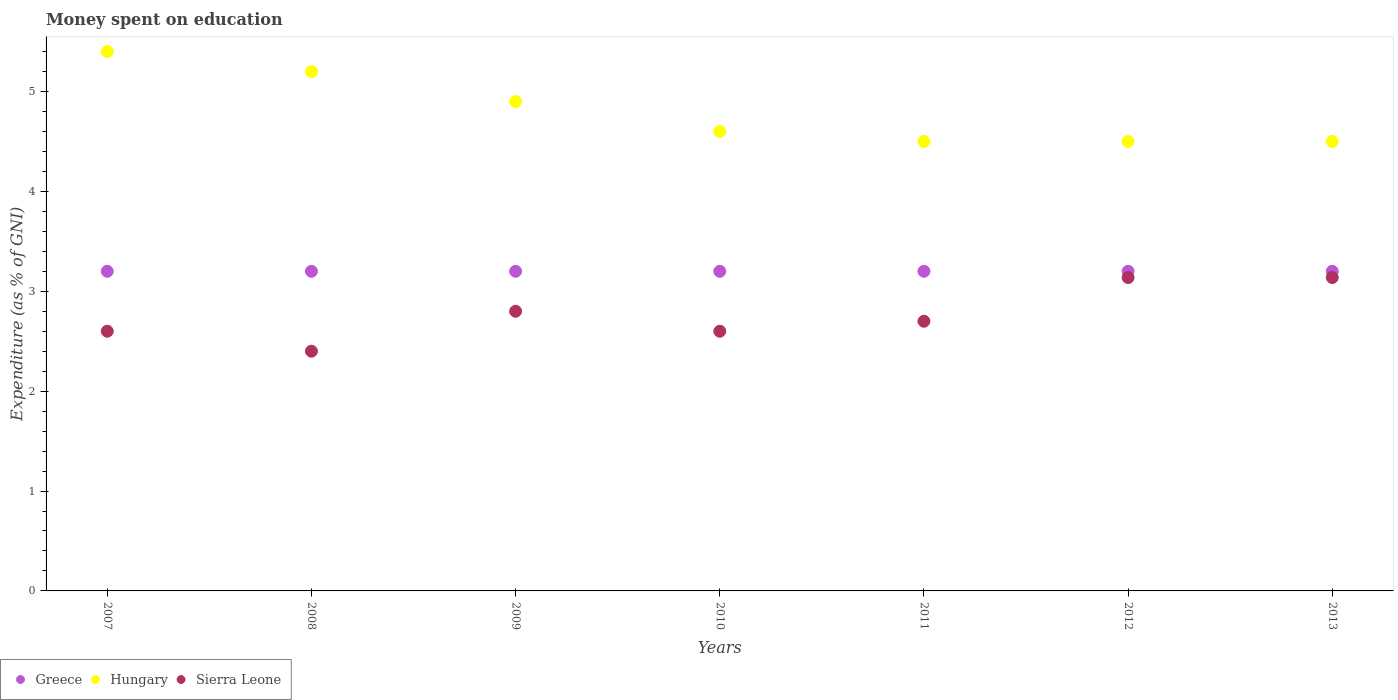What is the amount of money spent on education in Hungary in 2010?
Give a very brief answer. 4.6. Across all years, what is the maximum amount of money spent on education in Sierra Leone?
Your answer should be very brief. 3.14. Across all years, what is the minimum amount of money spent on education in Hungary?
Provide a short and direct response. 4.5. In which year was the amount of money spent on education in Sierra Leone minimum?
Your answer should be compact. 2008. What is the total amount of money spent on education in Greece in the graph?
Your response must be concise. 22.4. What is the difference between the amount of money spent on education in Sierra Leone in 2009 and that in 2013?
Your response must be concise. -0.34. What is the average amount of money spent on education in Hungary per year?
Keep it short and to the point. 4.8. In the year 2012, what is the difference between the amount of money spent on education in Sierra Leone and amount of money spent on education in Hungary?
Your answer should be very brief. -1.36. What is the ratio of the amount of money spent on education in Sierra Leone in 2010 to that in 2011?
Ensure brevity in your answer.  0.96. What is the difference between the highest and the second highest amount of money spent on education in Hungary?
Give a very brief answer. 0.2. Is the sum of the amount of money spent on education in Hungary in 2008 and 2009 greater than the maximum amount of money spent on education in Greece across all years?
Your response must be concise. Yes. Is it the case that in every year, the sum of the amount of money spent on education in Greece and amount of money spent on education in Sierra Leone  is greater than the amount of money spent on education in Hungary?
Offer a very short reply. Yes. Is the amount of money spent on education in Sierra Leone strictly greater than the amount of money spent on education in Greece over the years?
Your response must be concise. No. Is the amount of money spent on education in Hungary strictly less than the amount of money spent on education in Greece over the years?
Offer a very short reply. No. Are the values on the major ticks of Y-axis written in scientific E-notation?
Your answer should be very brief. No. Does the graph contain any zero values?
Ensure brevity in your answer.  No. What is the title of the graph?
Provide a succinct answer. Money spent on education. What is the label or title of the X-axis?
Ensure brevity in your answer.  Years. What is the label or title of the Y-axis?
Keep it short and to the point. Expenditure (as % of GNI). What is the Expenditure (as % of GNI) of Greece in 2007?
Your response must be concise. 3.2. What is the Expenditure (as % of GNI) of Sierra Leone in 2008?
Your answer should be very brief. 2.4. What is the Expenditure (as % of GNI) of Hungary in 2009?
Provide a succinct answer. 4.9. What is the Expenditure (as % of GNI) of Greece in 2010?
Your response must be concise. 3.2. What is the Expenditure (as % of GNI) of Sierra Leone in 2010?
Keep it short and to the point. 2.6. What is the Expenditure (as % of GNI) in Hungary in 2011?
Your response must be concise. 4.5. What is the Expenditure (as % of GNI) in Greece in 2012?
Your answer should be very brief. 3.2. What is the Expenditure (as % of GNI) of Sierra Leone in 2012?
Make the answer very short. 3.14. What is the Expenditure (as % of GNI) in Greece in 2013?
Offer a terse response. 3.2. What is the Expenditure (as % of GNI) of Sierra Leone in 2013?
Provide a short and direct response. 3.14. Across all years, what is the maximum Expenditure (as % of GNI) in Greece?
Offer a terse response. 3.2. Across all years, what is the maximum Expenditure (as % of GNI) in Sierra Leone?
Offer a terse response. 3.14. Across all years, what is the minimum Expenditure (as % of GNI) of Greece?
Offer a very short reply. 3.2. Across all years, what is the minimum Expenditure (as % of GNI) in Sierra Leone?
Provide a succinct answer. 2.4. What is the total Expenditure (as % of GNI) of Greece in the graph?
Provide a succinct answer. 22.4. What is the total Expenditure (as % of GNI) in Hungary in the graph?
Your answer should be compact. 33.6. What is the total Expenditure (as % of GNI) in Sierra Leone in the graph?
Provide a short and direct response. 19.37. What is the difference between the Expenditure (as % of GNI) of Greece in 2007 and that in 2008?
Make the answer very short. 0. What is the difference between the Expenditure (as % of GNI) in Hungary in 2007 and that in 2008?
Your answer should be compact. 0.2. What is the difference between the Expenditure (as % of GNI) in Sierra Leone in 2007 and that in 2008?
Make the answer very short. 0.2. What is the difference between the Expenditure (as % of GNI) of Greece in 2007 and that in 2009?
Your response must be concise. 0. What is the difference between the Expenditure (as % of GNI) of Hungary in 2007 and that in 2010?
Offer a very short reply. 0.8. What is the difference between the Expenditure (as % of GNI) of Sierra Leone in 2007 and that in 2010?
Your response must be concise. 0. What is the difference between the Expenditure (as % of GNI) of Sierra Leone in 2007 and that in 2011?
Offer a terse response. -0.1. What is the difference between the Expenditure (as % of GNI) in Greece in 2007 and that in 2012?
Make the answer very short. 0. What is the difference between the Expenditure (as % of GNI) in Hungary in 2007 and that in 2012?
Give a very brief answer. 0.9. What is the difference between the Expenditure (as % of GNI) of Sierra Leone in 2007 and that in 2012?
Offer a terse response. -0.54. What is the difference between the Expenditure (as % of GNI) of Sierra Leone in 2007 and that in 2013?
Your response must be concise. -0.54. What is the difference between the Expenditure (as % of GNI) in Greece in 2008 and that in 2009?
Keep it short and to the point. 0. What is the difference between the Expenditure (as % of GNI) of Greece in 2008 and that in 2011?
Keep it short and to the point. 0. What is the difference between the Expenditure (as % of GNI) of Hungary in 2008 and that in 2011?
Your answer should be compact. 0.7. What is the difference between the Expenditure (as % of GNI) of Hungary in 2008 and that in 2012?
Provide a succinct answer. 0.7. What is the difference between the Expenditure (as % of GNI) of Sierra Leone in 2008 and that in 2012?
Ensure brevity in your answer.  -0.74. What is the difference between the Expenditure (as % of GNI) in Greece in 2008 and that in 2013?
Provide a short and direct response. 0. What is the difference between the Expenditure (as % of GNI) of Hungary in 2008 and that in 2013?
Ensure brevity in your answer.  0.7. What is the difference between the Expenditure (as % of GNI) in Sierra Leone in 2008 and that in 2013?
Give a very brief answer. -0.74. What is the difference between the Expenditure (as % of GNI) in Greece in 2009 and that in 2010?
Provide a short and direct response. 0. What is the difference between the Expenditure (as % of GNI) in Hungary in 2009 and that in 2010?
Your answer should be compact. 0.3. What is the difference between the Expenditure (as % of GNI) of Sierra Leone in 2009 and that in 2010?
Make the answer very short. 0.2. What is the difference between the Expenditure (as % of GNI) of Hungary in 2009 and that in 2011?
Make the answer very short. 0.4. What is the difference between the Expenditure (as % of GNI) in Sierra Leone in 2009 and that in 2011?
Your answer should be compact. 0.1. What is the difference between the Expenditure (as % of GNI) of Greece in 2009 and that in 2012?
Provide a succinct answer. 0. What is the difference between the Expenditure (as % of GNI) of Sierra Leone in 2009 and that in 2012?
Give a very brief answer. -0.34. What is the difference between the Expenditure (as % of GNI) of Hungary in 2009 and that in 2013?
Your answer should be compact. 0.4. What is the difference between the Expenditure (as % of GNI) in Sierra Leone in 2009 and that in 2013?
Offer a terse response. -0.34. What is the difference between the Expenditure (as % of GNI) of Greece in 2010 and that in 2011?
Make the answer very short. 0. What is the difference between the Expenditure (as % of GNI) in Sierra Leone in 2010 and that in 2012?
Your answer should be very brief. -0.54. What is the difference between the Expenditure (as % of GNI) in Sierra Leone in 2010 and that in 2013?
Provide a short and direct response. -0.54. What is the difference between the Expenditure (as % of GNI) of Sierra Leone in 2011 and that in 2012?
Provide a succinct answer. -0.44. What is the difference between the Expenditure (as % of GNI) in Sierra Leone in 2011 and that in 2013?
Your answer should be compact. -0.44. What is the difference between the Expenditure (as % of GNI) in Greece in 2012 and that in 2013?
Offer a very short reply. 0. What is the difference between the Expenditure (as % of GNI) in Sierra Leone in 2012 and that in 2013?
Ensure brevity in your answer.  0. What is the difference between the Expenditure (as % of GNI) in Greece in 2007 and the Expenditure (as % of GNI) in Hungary in 2008?
Make the answer very short. -2. What is the difference between the Expenditure (as % of GNI) of Hungary in 2007 and the Expenditure (as % of GNI) of Sierra Leone in 2008?
Your answer should be very brief. 3. What is the difference between the Expenditure (as % of GNI) in Greece in 2007 and the Expenditure (as % of GNI) in Hungary in 2009?
Provide a short and direct response. -1.7. What is the difference between the Expenditure (as % of GNI) in Hungary in 2007 and the Expenditure (as % of GNI) in Sierra Leone in 2009?
Offer a very short reply. 2.6. What is the difference between the Expenditure (as % of GNI) of Greece in 2007 and the Expenditure (as % of GNI) of Hungary in 2010?
Make the answer very short. -1.4. What is the difference between the Expenditure (as % of GNI) of Greece in 2007 and the Expenditure (as % of GNI) of Sierra Leone in 2010?
Offer a very short reply. 0.6. What is the difference between the Expenditure (as % of GNI) of Hungary in 2007 and the Expenditure (as % of GNI) of Sierra Leone in 2010?
Ensure brevity in your answer.  2.8. What is the difference between the Expenditure (as % of GNI) of Greece in 2007 and the Expenditure (as % of GNI) of Hungary in 2011?
Your answer should be very brief. -1.3. What is the difference between the Expenditure (as % of GNI) of Greece in 2007 and the Expenditure (as % of GNI) of Sierra Leone in 2011?
Your answer should be compact. 0.5. What is the difference between the Expenditure (as % of GNI) in Greece in 2007 and the Expenditure (as % of GNI) in Sierra Leone in 2012?
Provide a succinct answer. 0.06. What is the difference between the Expenditure (as % of GNI) of Hungary in 2007 and the Expenditure (as % of GNI) of Sierra Leone in 2012?
Offer a very short reply. 2.26. What is the difference between the Expenditure (as % of GNI) in Greece in 2007 and the Expenditure (as % of GNI) in Hungary in 2013?
Provide a succinct answer. -1.3. What is the difference between the Expenditure (as % of GNI) in Greece in 2007 and the Expenditure (as % of GNI) in Sierra Leone in 2013?
Give a very brief answer. 0.06. What is the difference between the Expenditure (as % of GNI) in Hungary in 2007 and the Expenditure (as % of GNI) in Sierra Leone in 2013?
Offer a very short reply. 2.26. What is the difference between the Expenditure (as % of GNI) of Greece in 2008 and the Expenditure (as % of GNI) of Hungary in 2009?
Provide a short and direct response. -1.7. What is the difference between the Expenditure (as % of GNI) in Hungary in 2008 and the Expenditure (as % of GNI) in Sierra Leone in 2009?
Your response must be concise. 2.4. What is the difference between the Expenditure (as % of GNI) of Greece in 2008 and the Expenditure (as % of GNI) of Hungary in 2010?
Offer a very short reply. -1.4. What is the difference between the Expenditure (as % of GNI) of Hungary in 2008 and the Expenditure (as % of GNI) of Sierra Leone in 2010?
Your response must be concise. 2.6. What is the difference between the Expenditure (as % of GNI) of Hungary in 2008 and the Expenditure (as % of GNI) of Sierra Leone in 2011?
Your answer should be compact. 2.5. What is the difference between the Expenditure (as % of GNI) of Greece in 2008 and the Expenditure (as % of GNI) of Sierra Leone in 2012?
Your answer should be very brief. 0.06. What is the difference between the Expenditure (as % of GNI) in Hungary in 2008 and the Expenditure (as % of GNI) in Sierra Leone in 2012?
Your answer should be compact. 2.06. What is the difference between the Expenditure (as % of GNI) of Greece in 2008 and the Expenditure (as % of GNI) of Hungary in 2013?
Keep it short and to the point. -1.3. What is the difference between the Expenditure (as % of GNI) in Greece in 2008 and the Expenditure (as % of GNI) in Sierra Leone in 2013?
Make the answer very short. 0.06. What is the difference between the Expenditure (as % of GNI) in Hungary in 2008 and the Expenditure (as % of GNI) in Sierra Leone in 2013?
Ensure brevity in your answer.  2.06. What is the difference between the Expenditure (as % of GNI) in Greece in 2009 and the Expenditure (as % of GNI) in Sierra Leone in 2010?
Provide a succinct answer. 0.6. What is the difference between the Expenditure (as % of GNI) in Greece in 2009 and the Expenditure (as % of GNI) in Hungary in 2011?
Provide a succinct answer. -1.3. What is the difference between the Expenditure (as % of GNI) in Hungary in 2009 and the Expenditure (as % of GNI) in Sierra Leone in 2011?
Your answer should be compact. 2.2. What is the difference between the Expenditure (as % of GNI) of Greece in 2009 and the Expenditure (as % of GNI) of Sierra Leone in 2012?
Your answer should be compact. 0.06. What is the difference between the Expenditure (as % of GNI) in Hungary in 2009 and the Expenditure (as % of GNI) in Sierra Leone in 2012?
Make the answer very short. 1.76. What is the difference between the Expenditure (as % of GNI) of Greece in 2009 and the Expenditure (as % of GNI) of Sierra Leone in 2013?
Provide a short and direct response. 0.06. What is the difference between the Expenditure (as % of GNI) of Hungary in 2009 and the Expenditure (as % of GNI) of Sierra Leone in 2013?
Your answer should be compact. 1.76. What is the difference between the Expenditure (as % of GNI) of Greece in 2010 and the Expenditure (as % of GNI) of Hungary in 2011?
Your answer should be compact. -1.3. What is the difference between the Expenditure (as % of GNI) in Hungary in 2010 and the Expenditure (as % of GNI) in Sierra Leone in 2011?
Make the answer very short. 1.9. What is the difference between the Expenditure (as % of GNI) of Greece in 2010 and the Expenditure (as % of GNI) of Sierra Leone in 2012?
Your response must be concise. 0.06. What is the difference between the Expenditure (as % of GNI) of Hungary in 2010 and the Expenditure (as % of GNI) of Sierra Leone in 2012?
Offer a very short reply. 1.46. What is the difference between the Expenditure (as % of GNI) in Greece in 2010 and the Expenditure (as % of GNI) in Sierra Leone in 2013?
Keep it short and to the point. 0.06. What is the difference between the Expenditure (as % of GNI) of Hungary in 2010 and the Expenditure (as % of GNI) of Sierra Leone in 2013?
Your answer should be compact. 1.46. What is the difference between the Expenditure (as % of GNI) in Greece in 2011 and the Expenditure (as % of GNI) in Hungary in 2012?
Your answer should be very brief. -1.3. What is the difference between the Expenditure (as % of GNI) in Greece in 2011 and the Expenditure (as % of GNI) in Sierra Leone in 2012?
Keep it short and to the point. 0.06. What is the difference between the Expenditure (as % of GNI) in Hungary in 2011 and the Expenditure (as % of GNI) in Sierra Leone in 2012?
Ensure brevity in your answer.  1.36. What is the difference between the Expenditure (as % of GNI) in Greece in 2011 and the Expenditure (as % of GNI) in Hungary in 2013?
Give a very brief answer. -1.3. What is the difference between the Expenditure (as % of GNI) of Greece in 2011 and the Expenditure (as % of GNI) of Sierra Leone in 2013?
Provide a short and direct response. 0.06. What is the difference between the Expenditure (as % of GNI) in Hungary in 2011 and the Expenditure (as % of GNI) in Sierra Leone in 2013?
Ensure brevity in your answer.  1.36. What is the difference between the Expenditure (as % of GNI) of Greece in 2012 and the Expenditure (as % of GNI) of Hungary in 2013?
Keep it short and to the point. -1.3. What is the difference between the Expenditure (as % of GNI) in Greece in 2012 and the Expenditure (as % of GNI) in Sierra Leone in 2013?
Provide a short and direct response. 0.06. What is the difference between the Expenditure (as % of GNI) in Hungary in 2012 and the Expenditure (as % of GNI) in Sierra Leone in 2013?
Keep it short and to the point. 1.36. What is the average Expenditure (as % of GNI) in Sierra Leone per year?
Offer a very short reply. 2.77. In the year 2007, what is the difference between the Expenditure (as % of GNI) in Greece and Expenditure (as % of GNI) in Hungary?
Your answer should be compact. -2.2. In the year 2007, what is the difference between the Expenditure (as % of GNI) of Greece and Expenditure (as % of GNI) of Sierra Leone?
Ensure brevity in your answer.  0.6. In the year 2007, what is the difference between the Expenditure (as % of GNI) of Hungary and Expenditure (as % of GNI) of Sierra Leone?
Offer a very short reply. 2.8. In the year 2008, what is the difference between the Expenditure (as % of GNI) in Greece and Expenditure (as % of GNI) in Hungary?
Your response must be concise. -2. In the year 2008, what is the difference between the Expenditure (as % of GNI) in Greece and Expenditure (as % of GNI) in Sierra Leone?
Provide a short and direct response. 0.8. In the year 2010, what is the difference between the Expenditure (as % of GNI) of Greece and Expenditure (as % of GNI) of Hungary?
Give a very brief answer. -1.4. In the year 2010, what is the difference between the Expenditure (as % of GNI) of Hungary and Expenditure (as % of GNI) of Sierra Leone?
Ensure brevity in your answer.  2. In the year 2011, what is the difference between the Expenditure (as % of GNI) in Hungary and Expenditure (as % of GNI) in Sierra Leone?
Provide a short and direct response. 1.8. In the year 2012, what is the difference between the Expenditure (as % of GNI) in Greece and Expenditure (as % of GNI) in Hungary?
Offer a very short reply. -1.3. In the year 2012, what is the difference between the Expenditure (as % of GNI) of Greece and Expenditure (as % of GNI) of Sierra Leone?
Keep it short and to the point. 0.06. In the year 2012, what is the difference between the Expenditure (as % of GNI) in Hungary and Expenditure (as % of GNI) in Sierra Leone?
Make the answer very short. 1.36. In the year 2013, what is the difference between the Expenditure (as % of GNI) in Greece and Expenditure (as % of GNI) in Hungary?
Give a very brief answer. -1.3. In the year 2013, what is the difference between the Expenditure (as % of GNI) in Greece and Expenditure (as % of GNI) in Sierra Leone?
Give a very brief answer. 0.06. In the year 2013, what is the difference between the Expenditure (as % of GNI) of Hungary and Expenditure (as % of GNI) of Sierra Leone?
Offer a terse response. 1.36. What is the ratio of the Expenditure (as % of GNI) of Greece in 2007 to that in 2009?
Provide a succinct answer. 1. What is the ratio of the Expenditure (as % of GNI) in Hungary in 2007 to that in 2009?
Your answer should be compact. 1.1. What is the ratio of the Expenditure (as % of GNI) of Greece in 2007 to that in 2010?
Your answer should be compact. 1. What is the ratio of the Expenditure (as % of GNI) of Hungary in 2007 to that in 2010?
Provide a succinct answer. 1.17. What is the ratio of the Expenditure (as % of GNI) of Sierra Leone in 2007 to that in 2010?
Provide a short and direct response. 1. What is the ratio of the Expenditure (as % of GNI) in Hungary in 2007 to that in 2012?
Offer a terse response. 1.2. What is the ratio of the Expenditure (as % of GNI) of Sierra Leone in 2007 to that in 2012?
Your answer should be very brief. 0.83. What is the ratio of the Expenditure (as % of GNI) of Greece in 2007 to that in 2013?
Give a very brief answer. 1. What is the ratio of the Expenditure (as % of GNI) of Hungary in 2007 to that in 2013?
Ensure brevity in your answer.  1.2. What is the ratio of the Expenditure (as % of GNI) in Sierra Leone in 2007 to that in 2013?
Keep it short and to the point. 0.83. What is the ratio of the Expenditure (as % of GNI) of Greece in 2008 to that in 2009?
Make the answer very short. 1. What is the ratio of the Expenditure (as % of GNI) in Hungary in 2008 to that in 2009?
Make the answer very short. 1.06. What is the ratio of the Expenditure (as % of GNI) of Sierra Leone in 2008 to that in 2009?
Keep it short and to the point. 0.86. What is the ratio of the Expenditure (as % of GNI) of Hungary in 2008 to that in 2010?
Offer a terse response. 1.13. What is the ratio of the Expenditure (as % of GNI) of Greece in 2008 to that in 2011?
Make the answer very short. 1. What is the ratio of the Expenditure (as % of GNI) in Hungary in 2008 to that in 2011?
Your answer should be very brief. 1.16. What is the ratio of the Expenditure (as % of GNI) in Hungary in 2008 to that in 2012?
Give a very brief answer. 1.16. What is the ratio of the Expenditure (as % of GNI) in Sierra Leone in 2008 to that in 2012?
Ensure brevity in your answer.  0.76. What is the ratio of the Expenditure (as % of GNI) of Greece in 2008 to that in 2013?
Your response must be concise. 1. What is the ratio of the Expenditure (as % of GNI) in Hungary in 2008 to that in 2013?
Your response must be concise. 1.16. What is the ratio of the Expenditure (as % of GNI) of Sierra Leone in 2008 to that in 2013?
Ensure brevity in your answer.  0.76. What is the ratio of the Expenditure (as % of GNI) in Greece in 2009 to that in 2010?
Offer a very short reply. 1. What is the ratio of the Expenditure (as % of GNI) in Hungary in 2009 to that in 2010?
Offer a very short reply. 1.07. What is the ratio of the Expenditure (as % of GNI) in Hungary in 2009 to that in 2011?
Your answer should be compact. 1.09. What is the ratio of the Expenditure (as % of GNI) of Greece in 2009 to that in 2012?
Your response must be concise. 1. What is the ratio of the Expenditure (as % of GNI) of Hungary in 2009 to that in 2012?
Give a very brief answer. 1.09. What is the ratio of the Expenditure (as % of GNI) in Sierra Leone in 2009 to that in 2012?
Provide a short and direct response. 0.89. What is the ratio of the Expenditure (as % of GNI) in Hungary in 2009 to that in 2013?
Make the answer very short. 1.09. What is the ratio of the Expenditure (as % of GNI) in Sierra Leone in 2009 to that in 2013?
Make the answer very short. 0.89. What is the ratio of the Expenditure (as % of GNI) of Greece in 2010 to that in 2011?
Make the answer very short. 1. What is the ratio of the Expenditure (as % of GNI) of Hungary in 2010 to that in 2011?
Your answer should be very brief. 1.02. What is the ratio of the Expenditure (as % of GNI) in Sierra Leone in 2010 to that in 2011?
Keep it short and to the point. 0.96. What is the ratio of the Expenditure (as % of GNI) of Greece in 2010 to that in 2012?
Keep it short and to the point. 1. What is the ratio of the Expenditure (as % of GNI) of Hungary in 2010 to that in 2012?
Keep it short and to the point. 1.02. What is the ratio of the Expenditure (as % of GNI) of Sierra Leone in 2010 to that in 2012?
Make the answer very short. 0.83. What is the ratio of the Expenditure (as % of GNI) of Hungary in 2010 to that in 2013?
Your answer should be very brief. 1.02. What is the ratio of the Expenditure (as % of GNI) in Sierra Leone in 2010 to that in 2013?
Your answer should be very brief. 0.83. What is the ratio of the Expenditure (as % of GNI) of Greece in 2011 to that in 2012?
Offer a terse response. 1. What is the ratio of the Expenditure (as % of GNI) of Sierra Leone in 2011 to that in 2012?
Provide a short and direct response. 0.86. What is the ratio of the Expenditure (as % of GNI) in Sierra Leone in 2011 to that in 2013?
Give a very brief answer. 0.86. What is the ratio of the Expenditure (as % of GNI) of Hungary in 2012 to that in 2013?
Ensure brevity in your answer.  1. What is the ratio of the Expenditure (as % of GNI) in Sierra Leone in 2012 to that in 2013?
Your answer should be very brief. 1. What is the difference between the highest and the second highest Expenditure (as % of GNI) in Hungary?
Provide a short and direct response. 0.2. What is the difference between the highest and the second highest Expenditure (as % of GNI) of Sierra Leone?
Offer a very short reply. 0. What is the difference between the highest and the lowest Expenditure (as % of GNI) in Greece?
Offer a very short reply. 0. What is the difference between the highest and the lowest Expenditure (as % of GNI) of Hungary?
Provide a succinct answer. 0.9. What is the difference between the highest and the lowest Expenditure (as % of GNI) of Sierra Leone?
Ensure brevity in your answer.  0.74. 